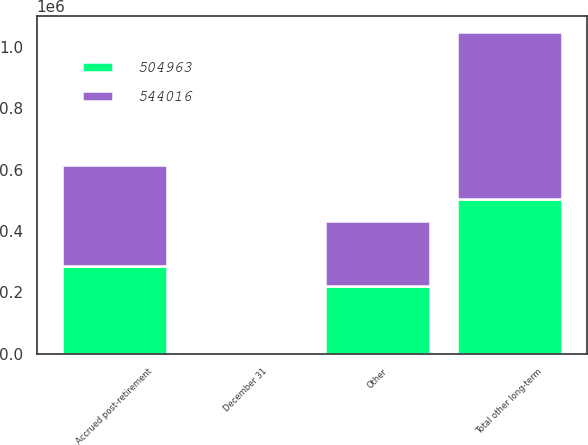<chart> <loc_0><loc_0><loc_500><loc_500><stacked_bar_chart><ecel><fcel>December 31<fcel>Accrued post-retirement<fcel>Other<fcel>Total other long-term<nl><fcel>504963<fcel>2008<fcel>285001<fcel>219962<fcel>504963<nl><fcel>544016<fcel>2007<fcel>330708<fcel>213308<fcel>544016<nl></chart> 